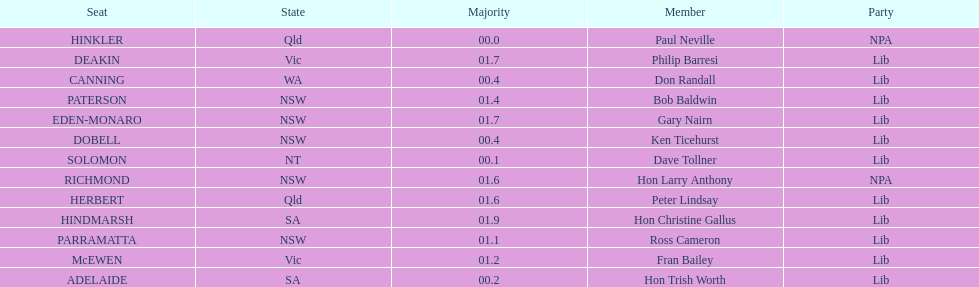What party had the most seats? Lib. 